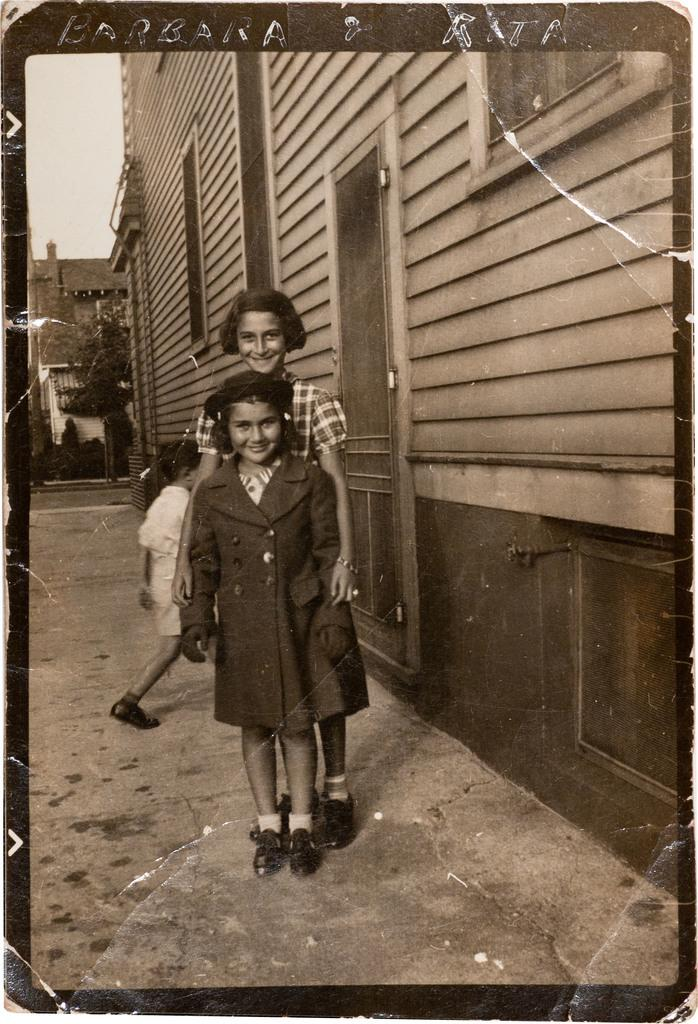How many people are in the image? There are three persons in the image. What is located at the bottom of the image? There is a road at the bottom of the image. What can be seen on the right side of the image? There is a building on the right side of the image. What type of image is this? The image appears to be a photograph. What type of arch can be seen in the image? There is no arch present in the image. Is there a rifle visible in the image? No, there is no rifle visible in the image. 